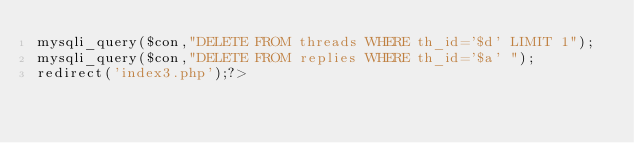<code> <loc_0><loc_0><loc_500><loc_500><_PHP_>mysqli_query($con,"DELETE FROM threads WHERE th_id='$d' LIMIT 1");
mysqli_query($con,"DELETE FROM replies WHERE th_id='$a' ");
redirect('index3.php');?>
</code> 